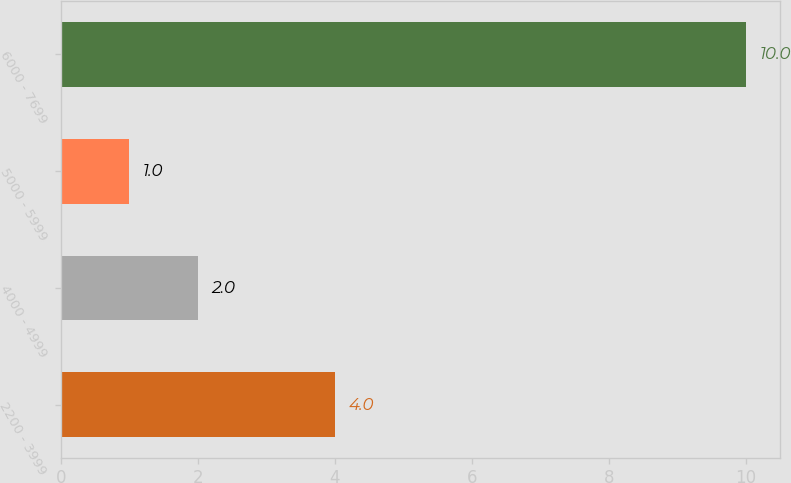<chart> <loc_0><loc_0><loc_500><loc_500><bar_chart><fcel>2200 - 3999<fcel>4000 - 4999<fcel>5000 - 5999<fcel>6000 - 7699<nl><fcel>4<fcel>2<fcel>1<fcel>10<nl></chart> 